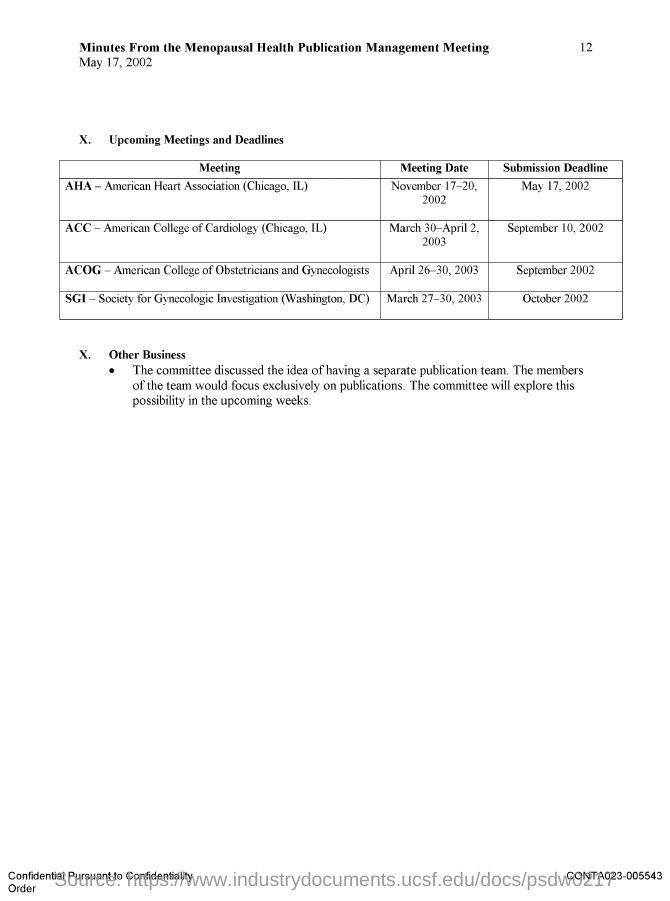Give some essential details in this illustration. The document in question is titled 'Minutes from the Menopausal Health Publication Management Meeting.' 